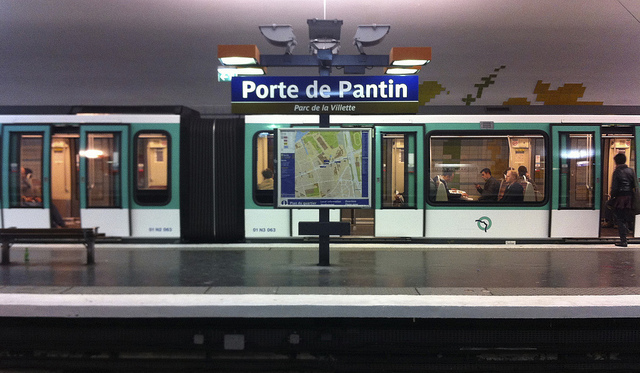Read all the text in this image. Porte de Pantin Pare Viwette 